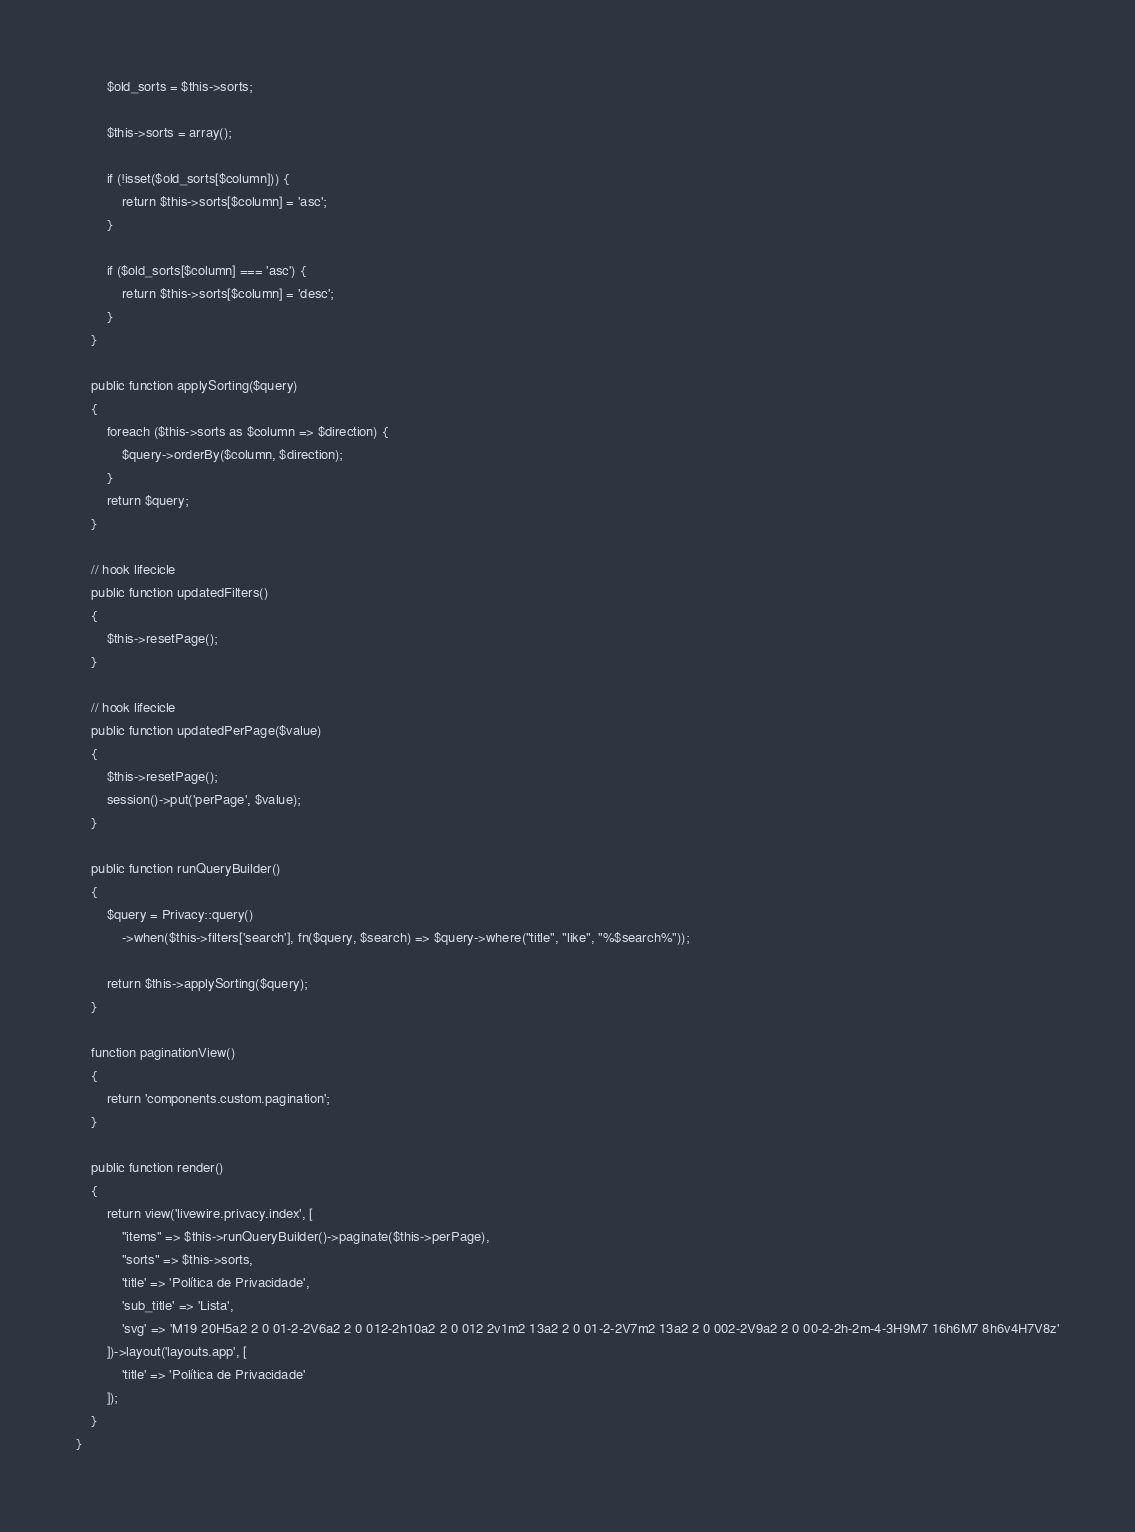<code> <loc_0><loc_0><loc_500><loc_500><_PHP_>        $old_sorts = $this->sorts;

        $this->sorts = array();

        if (!isset($old_sorts[$column])) {
            return $this->sorts[$column] = 'asc';
        }

        if ($old_sorts[$column] === 'asc') {
            return $this->sorts[$column] = 'desc';
        }
    }

    public function applySorting($query)
    {
        foreach ($this->sorts as $column => $direction) {
            $query->orderBy($column, $direction);
        }
        return $query;
    }

    // hook lifecicle
    public function updatedFilters()
    {
        $this->resetPage();
    }

    // hook lifecicle
    public function updatedPerPage($value)
    {
        $this->resetPage();
        session()->put('perPage', $value);
    }

    public function runQueryBuilder()
    {
        $query = Privacy::query()
            ->when($this->filters['search'], fn($query, $search) => $query->where("title", "like", "%$search%"));
        
        return $this->applySorting($query);
    }

    function paginationView()
    {
        return 'components.custom.pagination';
    }

    public function render()
    {
        return view('livewire.privacy.index', [
            "items" => $this->runQueryBuilder()->paginate($this->perPage),
            "sorts" => $this->sorts,
            'title' => 'Política de Privacidade',
            'sub_title' => 'Lista',
            'svg' => 'M19 20H5a2 2 0 01-2-2V6a2 2 0 012-2h10a2 2 0 012 2v1m2 13a2 2 0 01-2-2V7m2 13a2 2 0 002-2V9a2 2 0 00-2-2h-2m-4-3H9M7 16h6M7 8h6v4H7V8z'
        ])->layout('layouts.app', [
            'title' => 'Política de Privacidade'
        ]);
    }
}
</code> 